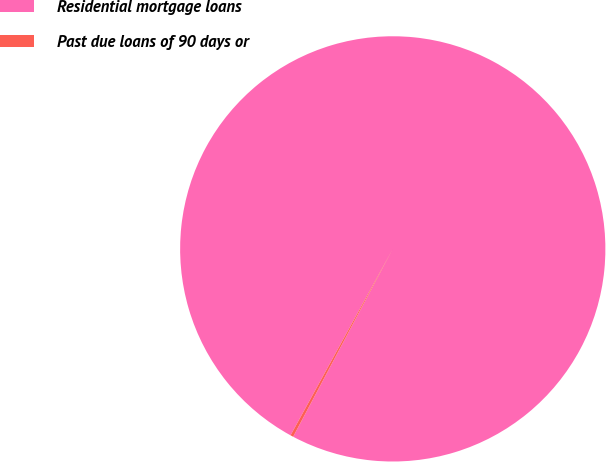<chart> <loc_0><loc_0><loc_500><loc_500><pie_chart><fcel>Residential mortgage loans<fcel>Past due loans of 90 days or<nl><fcel>99.78%<fcel>0.22%<nl></chart> 